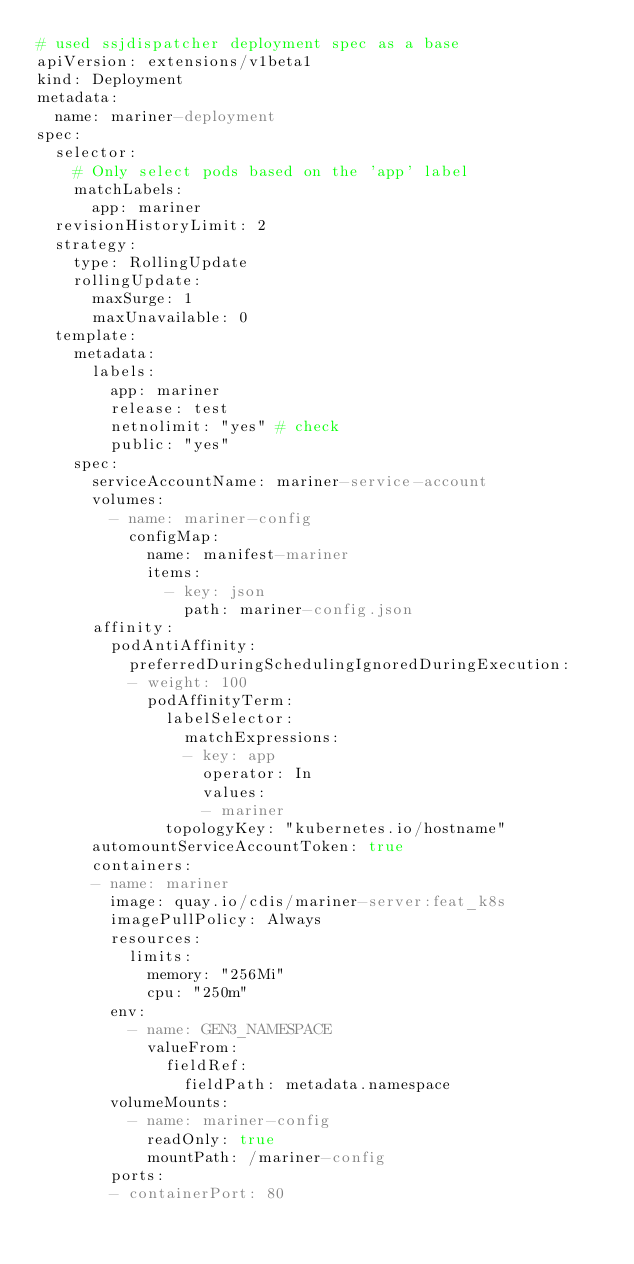Convert code to text. <code><loc_0><loc_0><loc_500><loc_500><_YAML_># used ssjdispatcher deployment spec as a base
apiVersion: extensions/v1beta1
kind: Deployment
metadata:
  name: mariner-deployment
spec:
  selector:
    # Only select pods based on the 'app' label
    matchLabels:
      app: mariner
  revisionHistoryLimit: 2
  strategy:
    type: RollingUpdate
    rollingUpdate:
      maxSurge: 1
      maxUnavailable: 0
  template:
    metadata:
      labels:
        app: mariner
        release: test
        netnolimit: "yes" # check
        public: "yes"
    spec:
      serviceAccountName: mariner-service-account
      volumes:
        - name: mariner-config
          configMap:
            name: manifest-mariner
            items:
              - key: json
                path: mariner-config.json
      affinity:
        podAntiAffinity:
          preferredDuringSchedulingIgnoredDuringExecution:
          - weight: 100
            podAffinityTerm:
              labelSelector:
                matchExpressions:
                - key: app
                  operator: In
                  values:
                  - mariner
              topologyKey: "kubernetes.io/hostname"
      automountServiceAccountToken: true
      containers:
      - name: mariner
        image: quay.io/cdis/mariner-server:feat_k8s
        imagePullPolicy: Always
        resources:
          limits:
            memory: "256Mi"
            cpu: "250m"
        env:
          - name: GEN3_NAMESPACE
            valueFrom:
              fieldRef:
                fieldPath: metadata.namespace
        volumeMounts:
          - name: mariner-config
            readOnly: true
            mountPath: /mariner-config
        ports:
        - containerPort: 80
</code> 